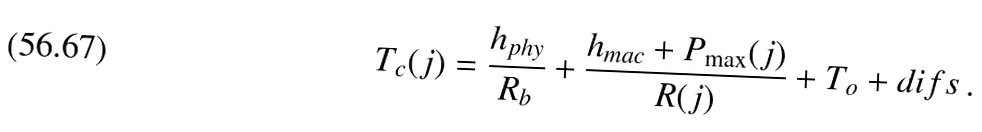<formula> <loc_0><loc_0><loc_500><loc_500>T _ { c } ( j ) = \frac { h _ { p h y } } { R _ { b } } + \frac { h _ { m a c } + P _ { \max } ( j ) } { R ( j ) } + T _ { o } + { d i f s } \, .</formula> 